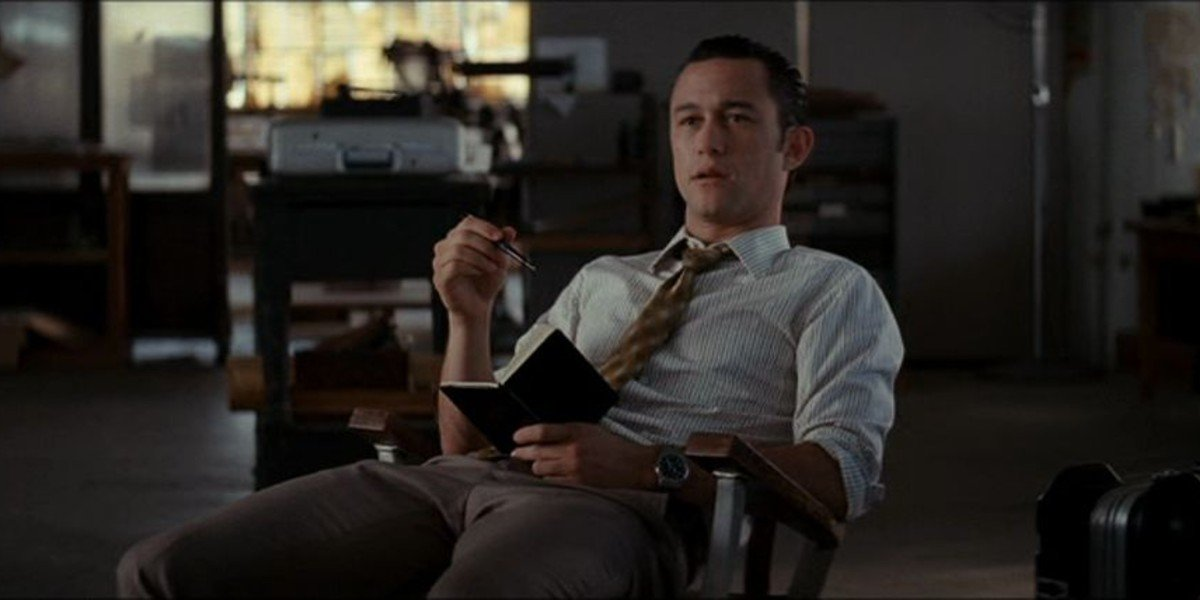Create a fictional backstory for this scene. In a bustling city, John is a strategic consultant known for his innovative approach and sharp intellect. He has just returned from a high-stakes client meeting and is taking a moment to gather his thoughts and prepare for the next big challenge. The black book he holds is his trusted journal, filled with groundbreaking ideas and critical notes. As he sits in his office, he reflects on the meeting and strategizes his next move, knowing that his decisions have a significant impact on the company’s future. 